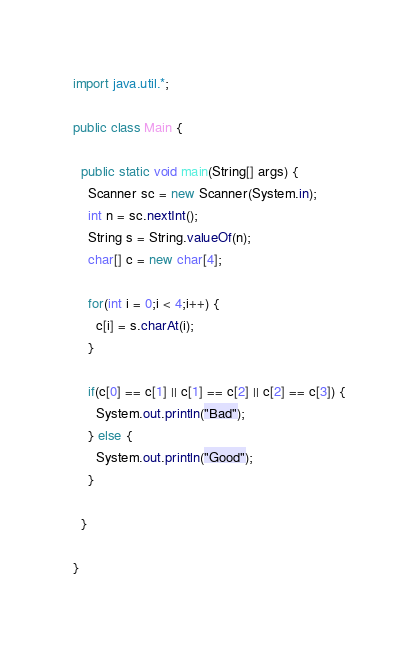Convert code to text. <code><loc_0><loc_0><loc_500><loc_500><_Java_>import java.util.*;

public class Main {

  public static void main(String[] args) {
    Scanner sc = new Scanner(System.in);
    int n = sc.nextInt();
    String s = String.valueOf(n);
    char[] c = new char[4];

    for(int i = 0;i < 4;i++) {
      c[i] = s.charAt(i);
    }

    if(c[0] == c[1] || c[1] == c[2] || c[2] == c[3]) {
      System.out.println("Bad");
    } else {
      System.out.println("Good");
    }

  }

}
</code> 